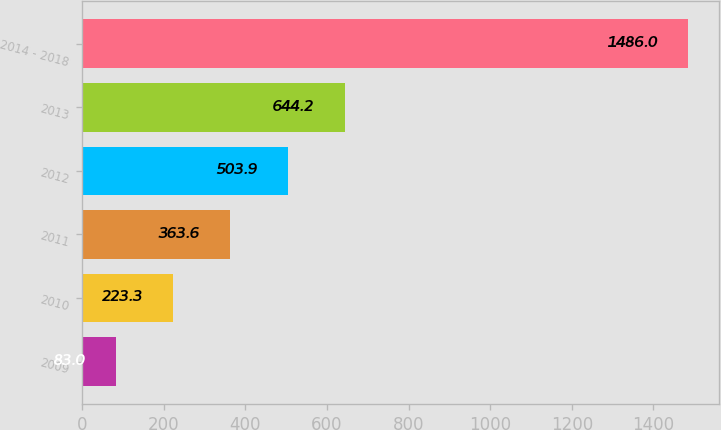<chart> <loc_0><loc_0><loc_500><loc_500><bar_chart><fcel>2009<fcel>2010<fcel>2011<fcel>2012<fcel>2013<fcel>2014 - 2018<nl><fcel>83<fcel>223.3<fcel>363.6<fcel>503.9<fcel>644.2<fcel>1486<nl></chart> 